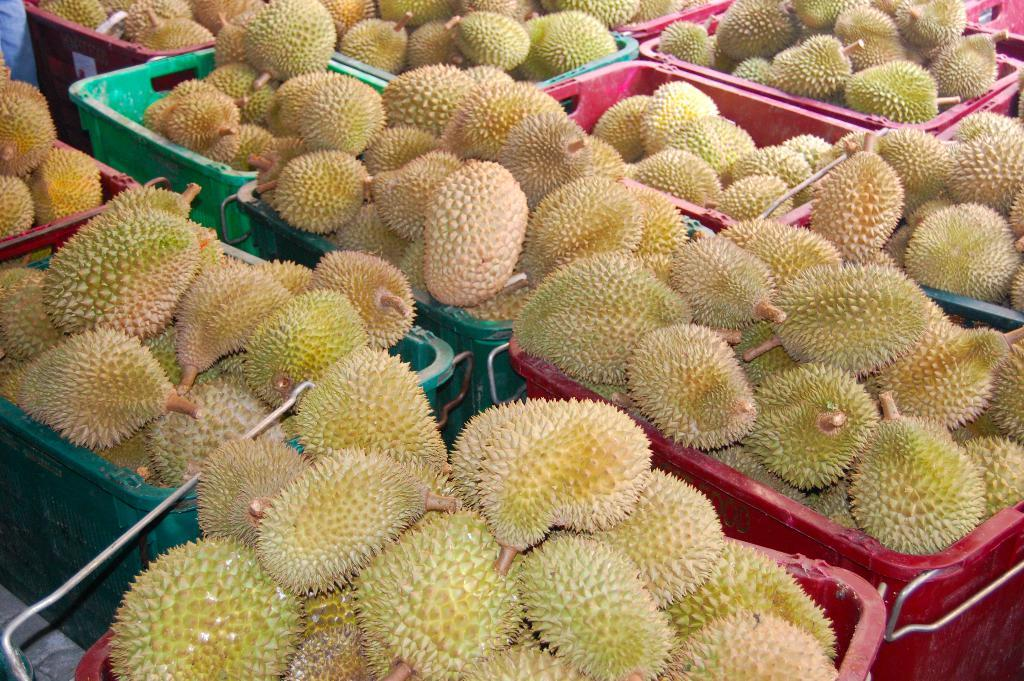What type of fruits are in the image? There are Durian fruits in the image. How are the Durian fruits stored in the image? The Durian fruits are kept in containers. Where are the containers with Durian fruits located in the image? The containers are in the middle of the image. What type of instrument is being played in the prison in the image? There is no instrument or prison present in the image; it only features Durian fruits in fruits in containers. 